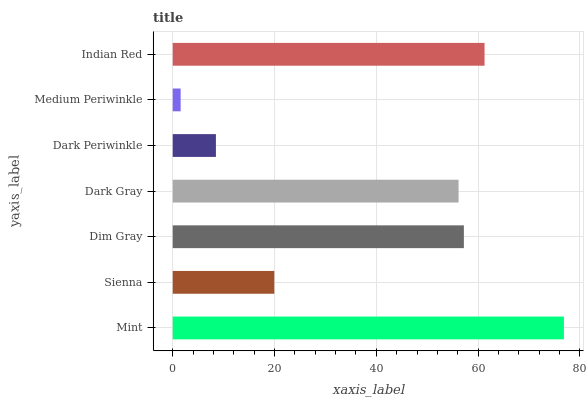Is Medium Periwinkle the minimum?
Answer yes or no. Yes. Is Mint the maximum?
Answer yes or no. Yes. Is Sienna the minimum?
Answer yes or no. No. Is Sienna the maximum?
Answer yes or no. No. Is Mint greater than Sienna?
Answer yes or no. Yes. Is Sienna less than Mint?
Answer yes or no. Yes. Is Sienna greater than Mint?
Answer yes or no. No. Is Mint less than Sienna?
Answer yes or no. No. Is Dark Gray the high median?
Answer yes or no. Yes. Is Dark Gray the low median?
Answer yes or no. Yes. Is Dark Periwinkle the high median?
Answer yes or no. No. Is Medium Periwinkle the low median?
Answer yes or no. No. 